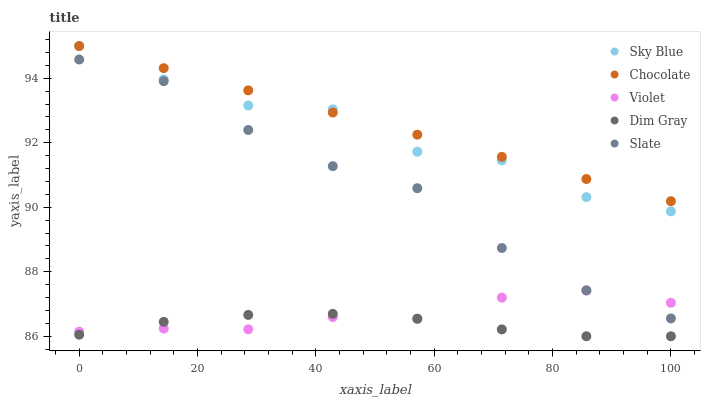Does Dim Gray have the minimum area under the curve?
Answer yes or no. Yes. Does Chocolate have the maximum area under the curve?
Answer yes or no. Yes. Does Violet have the minimum area under the curve?
Answer yes or no. No. Does Violet have the maximum area under the curve?
Answer yes or no. No. Is Chocolate the smoothest?
Answer yes or no. Yes. Is Sky Blue the roughest?
Answer yes or no. Yes. Is Dim Gray the smoothest?
Answer yes or no. No. Is Dim Gray the roughest?
Answer yes or no. No. Does Dim Gray have the lowest value?
Answer yes or no. Yes. Does Violet have the lowest value?
Answer yes or no. No. Does Chocolate have the highest value?
Answer yes or no. Yes. Does Violet have the highest value?
Answer yes or no. No. Is Dim Gray less than Chocolate?
Answer yes or no. Yes. Is Slate greater than Dim Gray?
Answer yes or no. Yes. Does Chocolate intersect Sky Blue?
Answer yes or no. Yes. Is Chocolate less than Sky Blue?
Answer yes or no. No. Is Chocolate greater than Sky Blue?
Answer yes or no. No. Does Dim Gray intersect Chocolate?
Answer yes or no. No. 